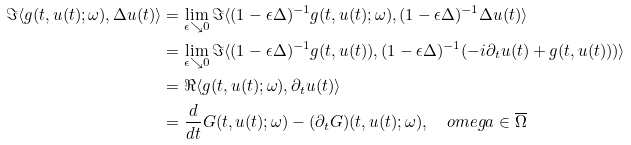Convert formula to latex. <formula><loc_0><loc_0><loc_500><loc_500>\Im \langle g ( t , u ( t ) ; \omega ) , \Delta u ( t ) \rangle & = \lim _ { \epsilon \searrow 0 } \Im \langle ( 1 - \epsilon \Delta ) ^ { - 1 } g ( t , u ( t ) ; \omega ) , ( 1 - \epsilon \Delta ) ^ { - 1 } \Delta u ( t ) \rangle \\ & = \lim _ { \epsilon \searrow 0 } \Im \langle ( 1 - \epsilon \Delta ) ^ { - 1 } g ( t , u ( t ) ) , ( 1 - \epsilon \Delta ) ^ { - 1 } ( - i \partial _ { t } u ( t ) + g ( t , u ( t ) ) ) \rangle \\ & = \Re \langle g ( t , u ( t ) ; \omega ) , \partial _ { t } u ( t ) \rangle \\ & = \frac { d } { d t } G ( t , u ( t ) ; \omega ) - ( \partial _ { t } G ) ( t , u ( t ) ; \omega ) , \quad o m e g a \in \overline { \Omega }</formula> 